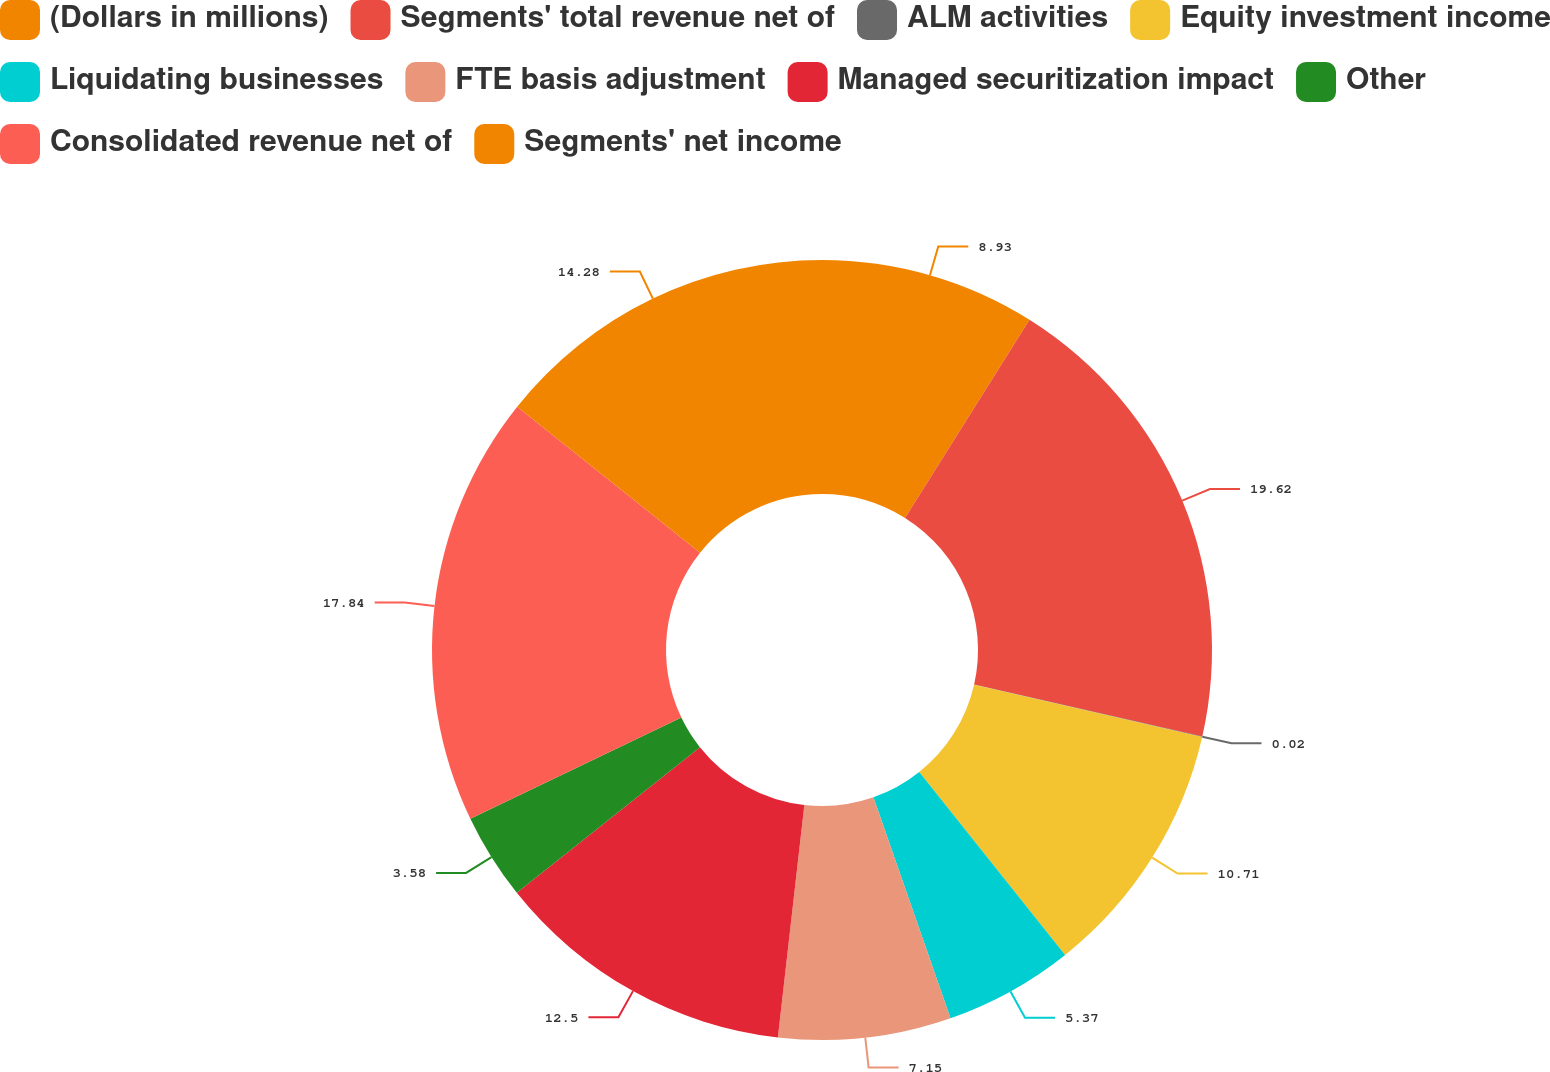<chart> <loc_0><loc_0><loc_500><loc_500><pie_chart><fcel>(Dollars in millions)<fcel>Segments' total revenue net of<fcel>ALM activities<fcel>Equity investment income<fcel>Liquidating businesses<fcel>FTE basis adjustment<fcel>Managed securitization impact<fcel>Other<fcel>Consolidated revenue net of<fcel>Segments' net income<nl><fcel>8.93%<fcel>19.63%<fcel>0.02%<fcel>10.71%<fcel>5.37%<fcel>7.15%<fcel>12.5%<fcel>3.58%<fcel>17.84%<fcel>14.28%<nl></chart> 